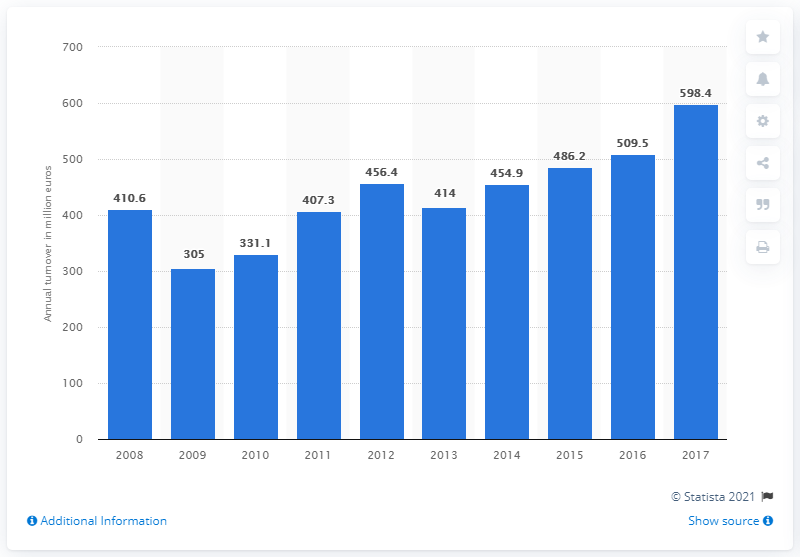Indicate a few pertinent items in this graphic. According to the data from 2017, the turnover of the textile manufacturing industry in Hungary was 598.4 million. 